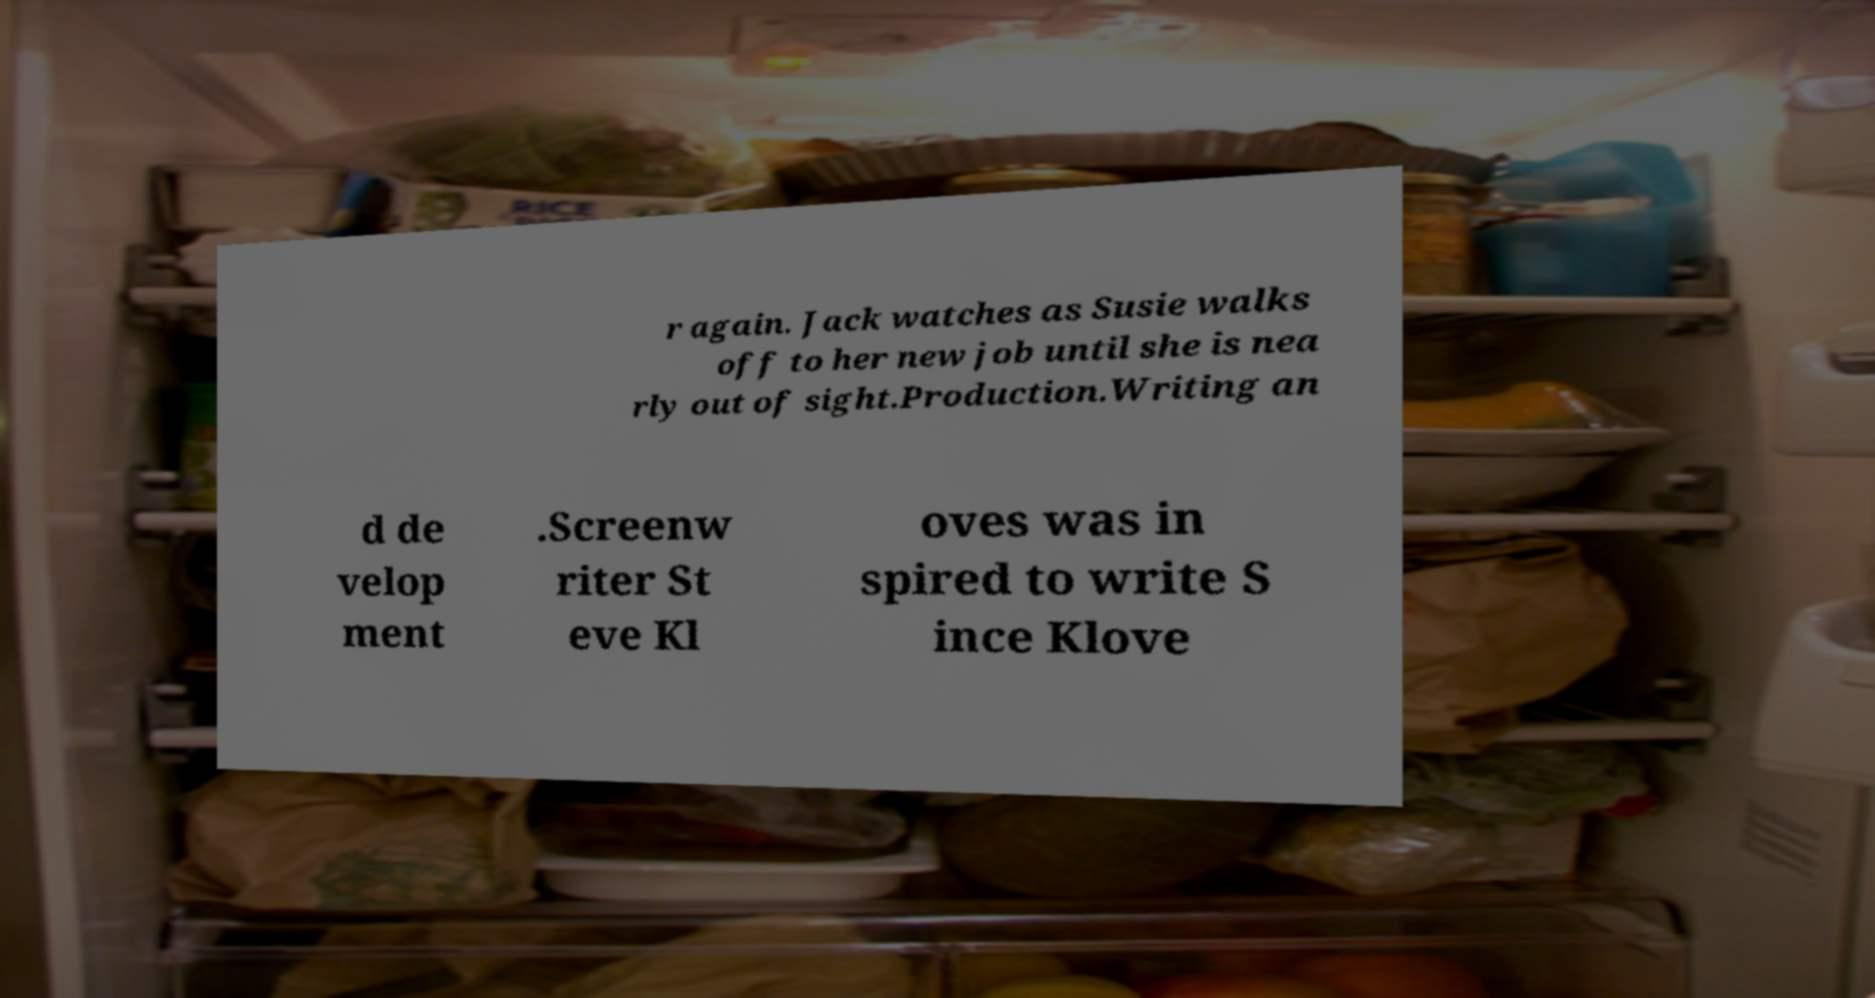What messages or text are displayed in this image? I need them in a readable, typed format. r again. Jack watches as Susie walks off to her new job until she is nea rly out of sight.Production.Writing an d de velop ment .Screenw riter St eve Kl oves was in spired to write S ince Klove 